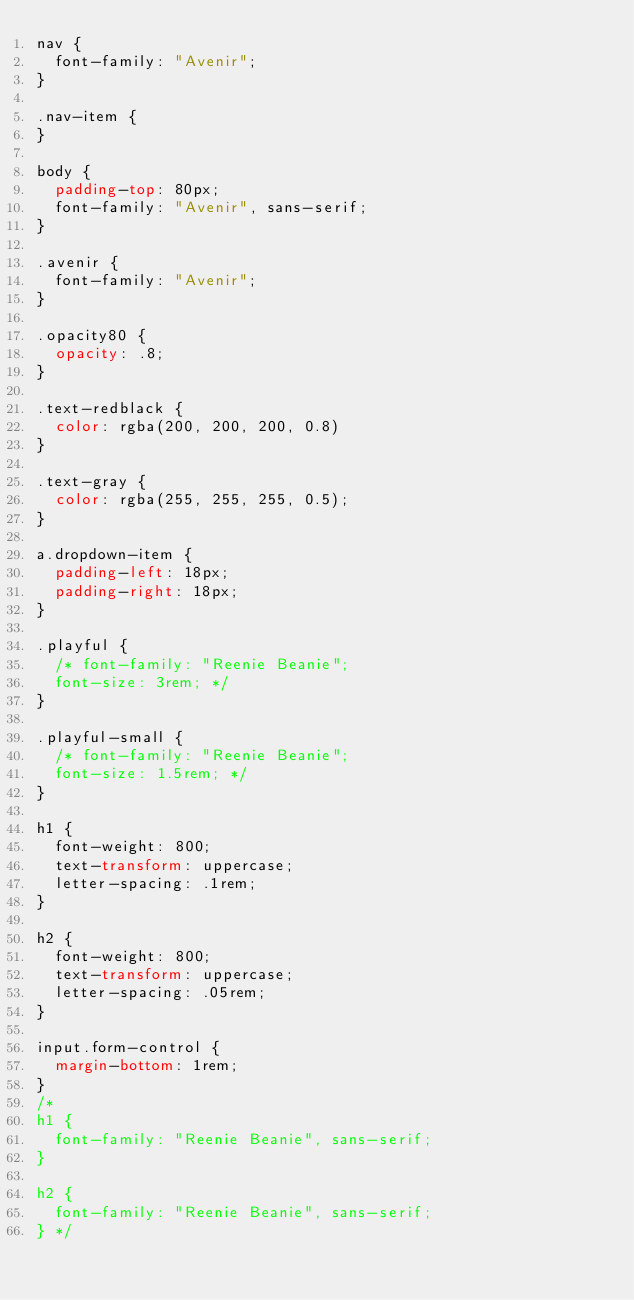Convert code to text. <code><loc_0><loc_0><loc_500><loc_500><_CSS_>nav {
  font-family: "Avenir";
}

.nav-item {
}

body {
  padding-top: 80px;
  font-family: "Avenir", sans-serif;
}

.avenir {
  font-family: "Avenir";
}

.opacity80 {
  opacity: .8;
}

.text-redblack {
  color: rgba(200, 200, 200, 0.8)
}

.text-gray {
  color: rgba(255, 255, 255, 0.5);
}

a.dropdown-item {
  padding-left: 18px;
  padding-right: 18px;
}

.playful {
  /* font-family: "Reenie Beanie";
  font-size: 3rem; */
}

.playful-small {
  /* font-family: "Reenie Beanie";
  font-size: 1.5rem; */
}

h1 {
  font-weight: 800;
  text-transform: uppercase;
  letter-spacing: .1rem;
}

h2 {
  font-weight: 800;
  text-transform: uppercase;
  letter-spacing: .05rem;
}

input.form-control {
  margin-bottom: 1rem;
}
/*
h1 {
  font-family: "Reenie Beanie", sans-serif;
}

h2 {
  font-family: "Reenie Beanie", sans-serif;
} */
</code> 